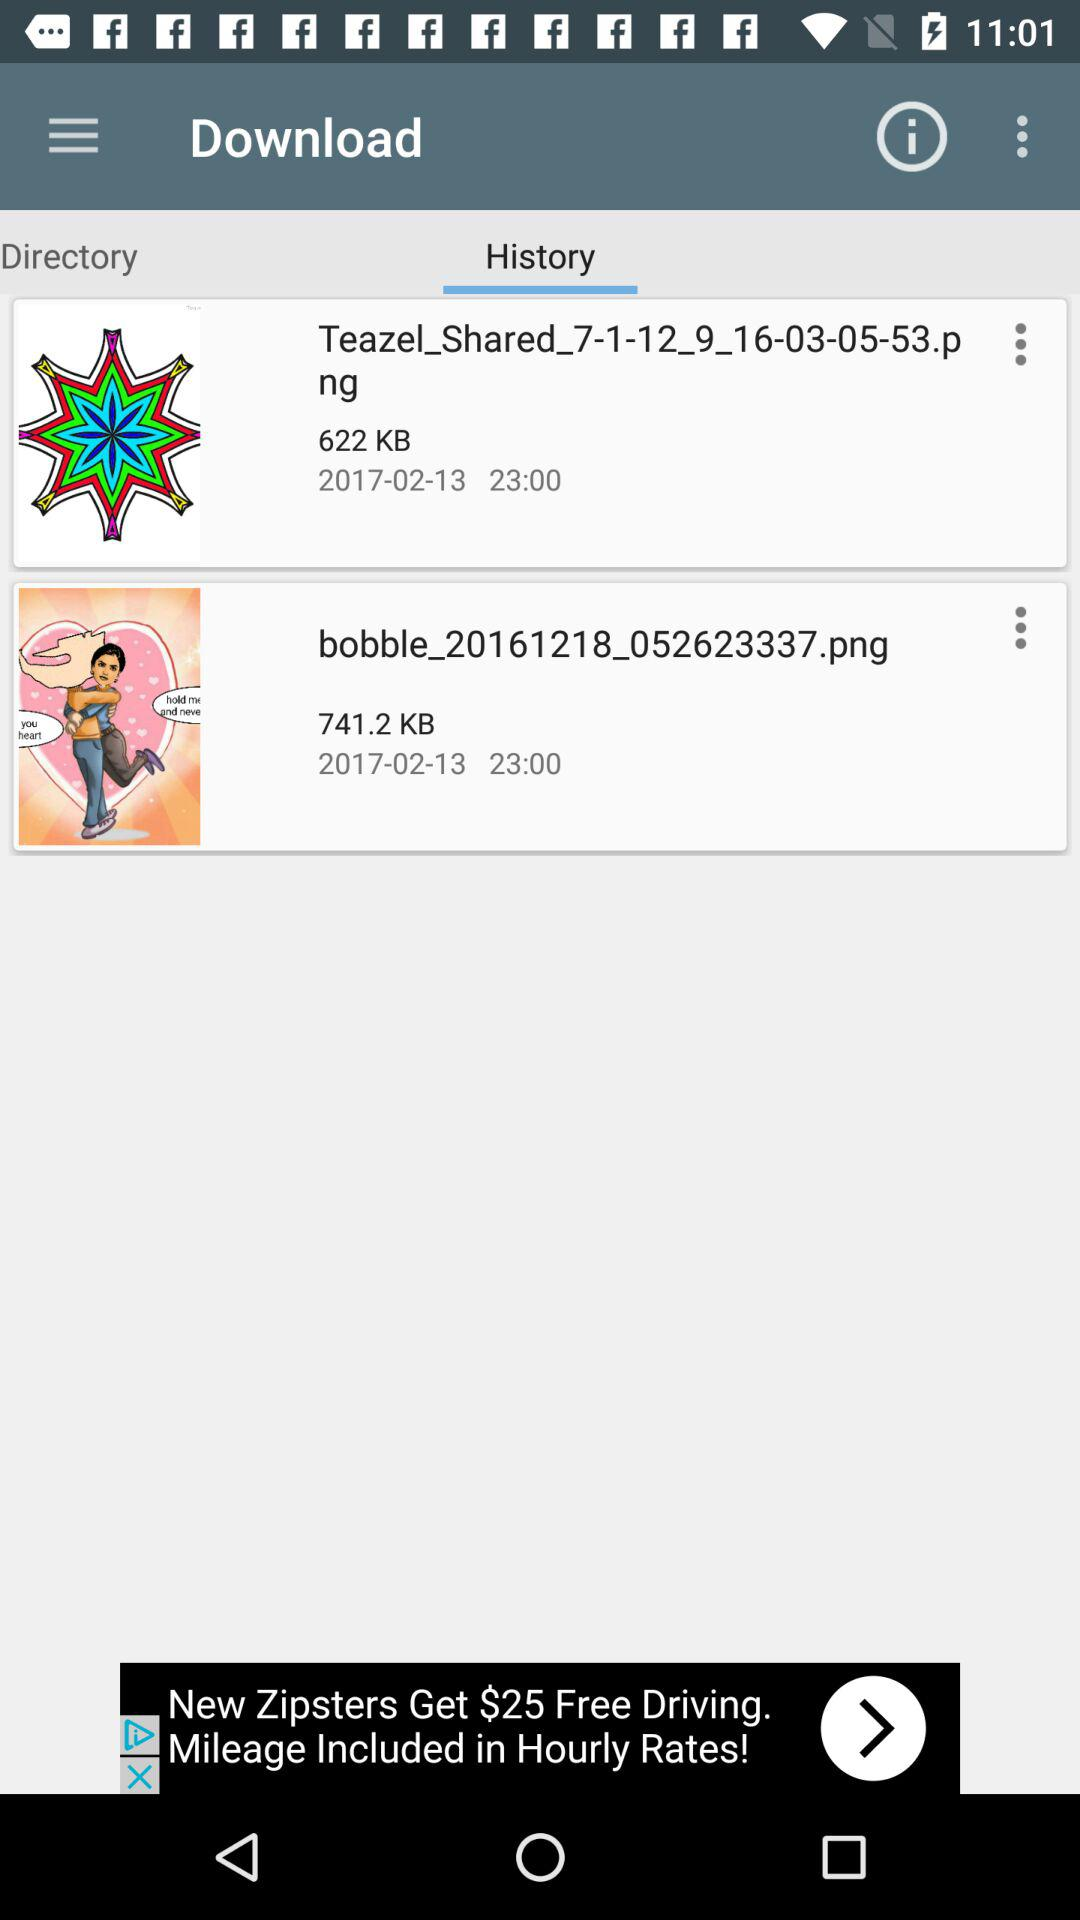How many more KBs is the second file than the first?
Answer the question using a single word or phrase. 119.2 